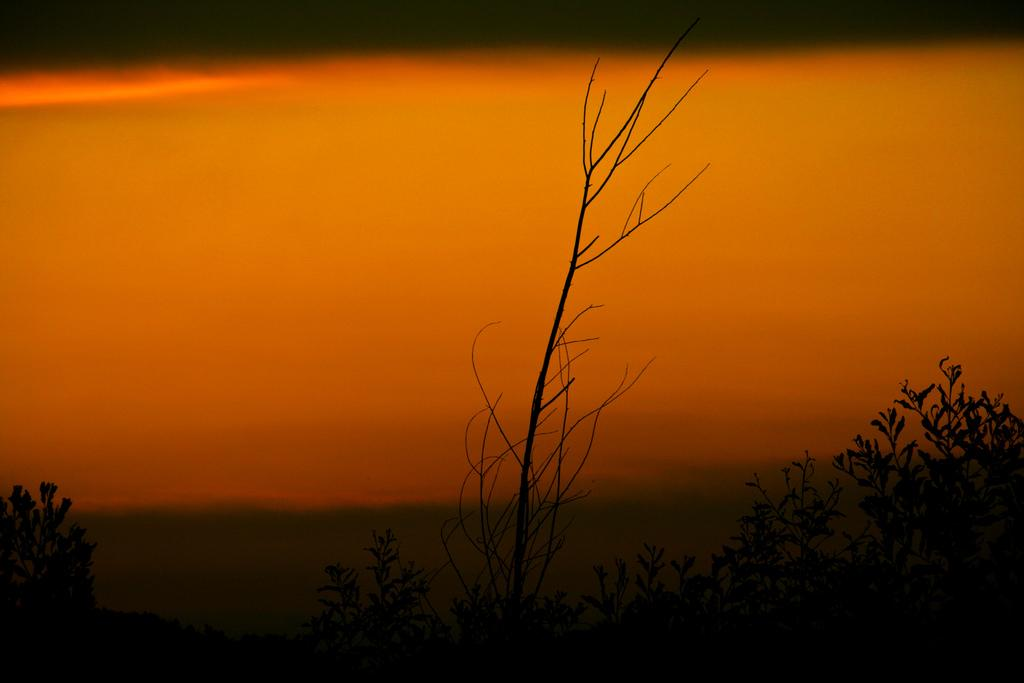What is visible at the top of the image? The sky is visible at the top of the image. What color is the sky in the image? The sky is orange in color. What type of vegetation is at the bottom of the image? There are plants at the bottom of the image. Can you see any deer in the image? There are no deer present in the image. What type of leather is visible in the image? There is no leather present in the image. 